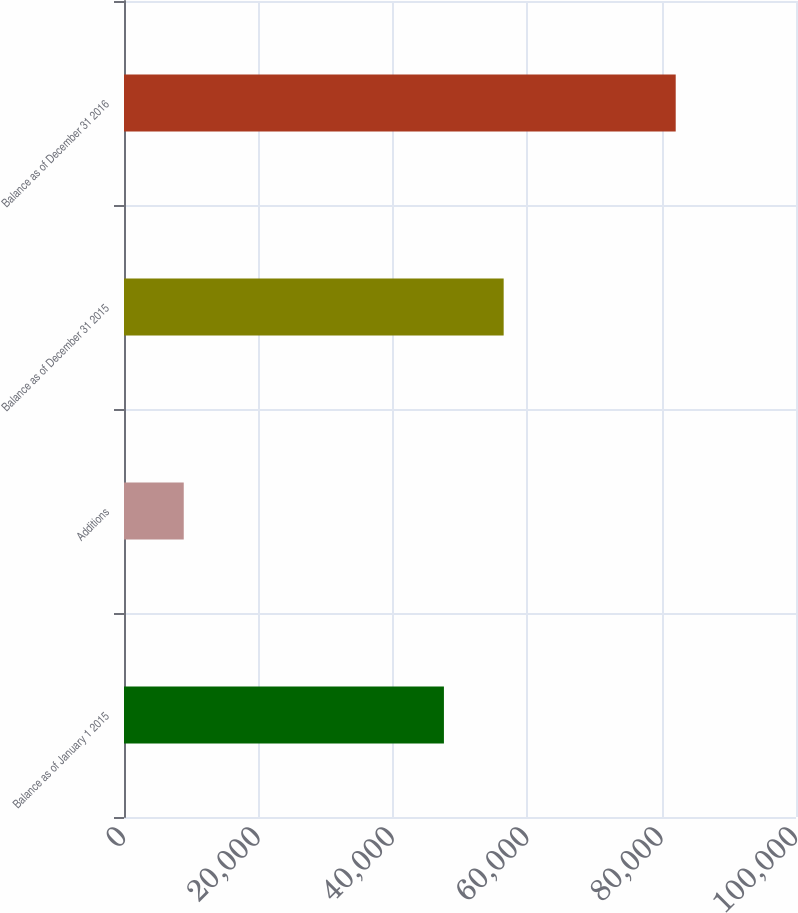Convert chart to OTSL. <chart><loc_0><loc_0><loc_500><loc_500><bar_chart><fcel>Balance as of January 1 2015<fcel>Additions<fcel>Balance as of December 31 2015<fcel>Balance as of December 31 2016<nl><fcel>47608<fcel>8891<fcel>56499<fcel>82100<nl></chart> 